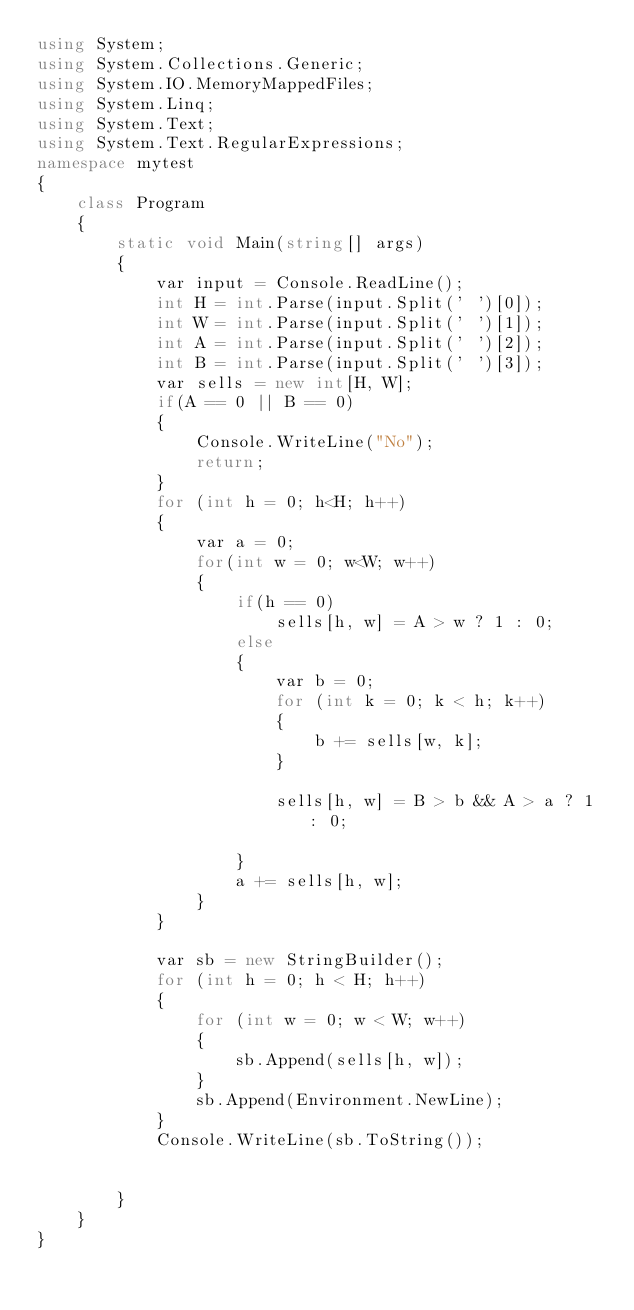Convert code to text. <code><loc_0><loc_0><loc_500><loc_500><_C#_>using System;
using System.Collections.Generic;
using System.IO.MemoryMappedFiles;
using System.Linq;
using System.Text;
using System.Text.RegularExpressions;
namespace mytest
{
    class Program
    {
        static void Main(string[] args)
        {
            var input = Console.ReadLine();
            int H = int.Parse(input.Split(' ')[0]);
            int W = int.Parse(input.Split(' ')[1]);
            int A = int.Parse(input.Split(' ')[2]);
            int B = int.Parse(input.Split(' ')[3]);
            var sells = new int[H, W];           
            if(A == 0 || B == 0)
            {
                Console.WriteLine("No");
                return;
            }
            for (int h = 0; h<H; h++)
            {
                var a = 0;
                for(int w = 0; w<W; w++)
                {
                    if(h == 0)
                        sells[h, w] = A > w ? 1 : 0;
                    else
                    {
                        var b = 0;
                        for (int k = 0; k < h; k++)
                        {
                            b += sells[w, k];
                        }

                        sells[h, w] = B > b && A > a ? 1 : 0;
                        
                    }
                    a += sells[h, w];
                }
            }

            var sb = new StringBuilder();
            for (int h = 0; h < H; h++)
            {
                for (int w = 0; w < W; w++)
                {
                    sb.Append(sells[h, w]);
                }
                sb.Append(Environment.NewLine);
            }
            Console.WriteLine(sb.ToString());


        }
    }
}
</code> 